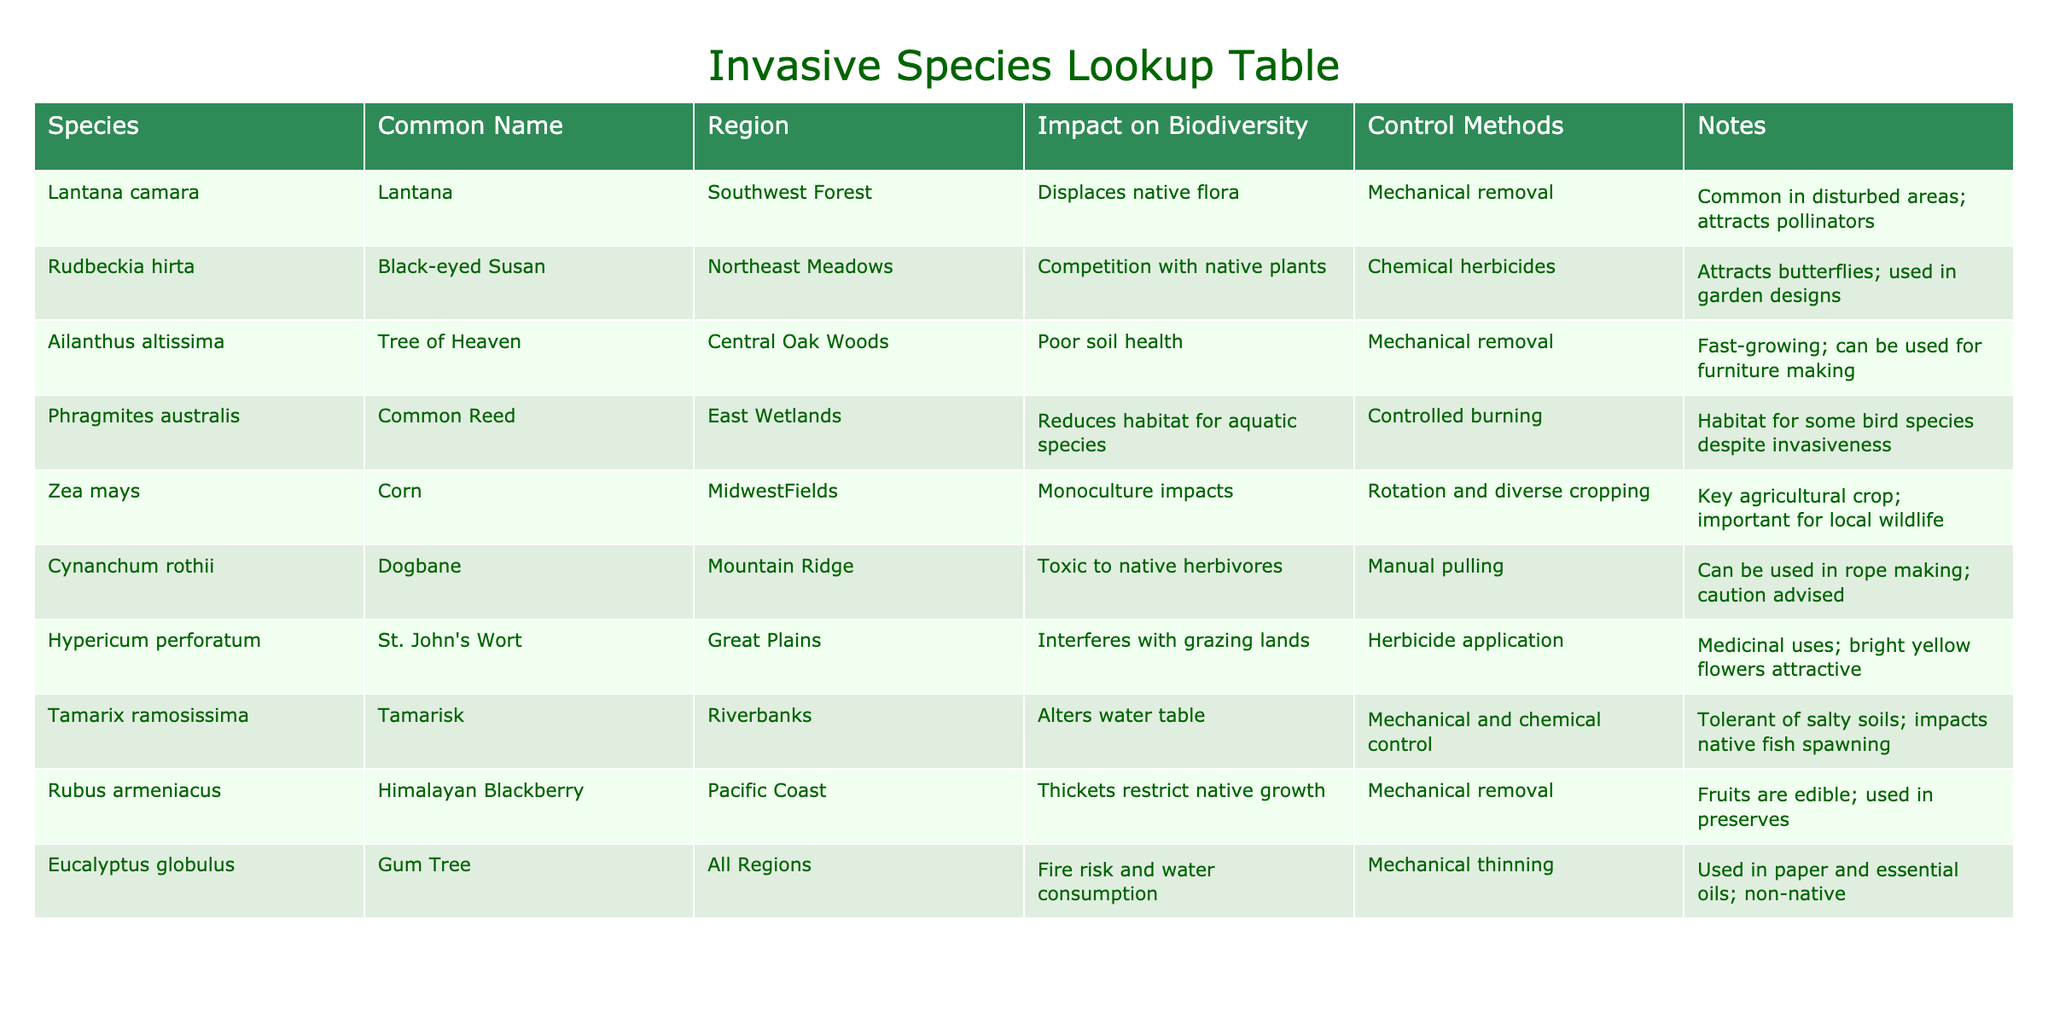What is the impact of Lantana camara on biodiversity? The table indicates that Lantana camara, also known as Lantana, displaces native flora, which negatively affects local biodiversity by reducing the number of native plant species.
Answer: Displaces native flora Which control method is listed for Tamarisk? The table specifies that both mechanical and chemical control methods are employed to manage Tamarisk, also known as Tamarix.
Answer: Mechanical and chemical control Is Corn considered an invasive species in the Midwest Fields? The table does not categorize Corn, or Zea mays, as an invasive species; instead, it highlights its role as a key agricultural crop impacting biodiversity due to monoculture practices. Therefore, the answer is no.
Answer: No How many invasive species listed have impacts related to water? Upon reviewing the table, Tamarisk is noted for altering the water table, and Eucalyptus globulus is associated with water consumption. This totals two species with water-related impacts.
Answer: 2 What are the combined control methods for the two species that affect the grazing lands? The table specifies that Hypericum perforatum (St. John's Wort) uses herbicide application, while no specific control method is listed for other grazing-impacting species. However, since only Hypericum has a defined method in that category, we consider just that.
Answer: Herbicide application Which invasive species attracts butterflies and where is it primarily found? The table mentions that Black-eyed Susan, or Rudbeckia hirta, attracts butterflies and is found in the Northeast Meadows region.
Answer: Northeast Meadows What species has the potential to be used in furniture making? The table indicates that Ailanthus altissima, known as Tree of Heaven, can be used for furniture making.
Answer: Tree of Heaven How does the impact on biodiversity vary among the species listed in the table? The table presents various impacts, ranging from displacement of native flora (Lantana) to competition with native plants (Black-eyed Susan), while some, like Phragmites australis, even provide habitat for certain bird species despite being invasive. Determining the average impact requires analyzing to classify them by severity. However, this indicates significant variability in biodiversity impacts depending on the species.
Answer: Varies widely 